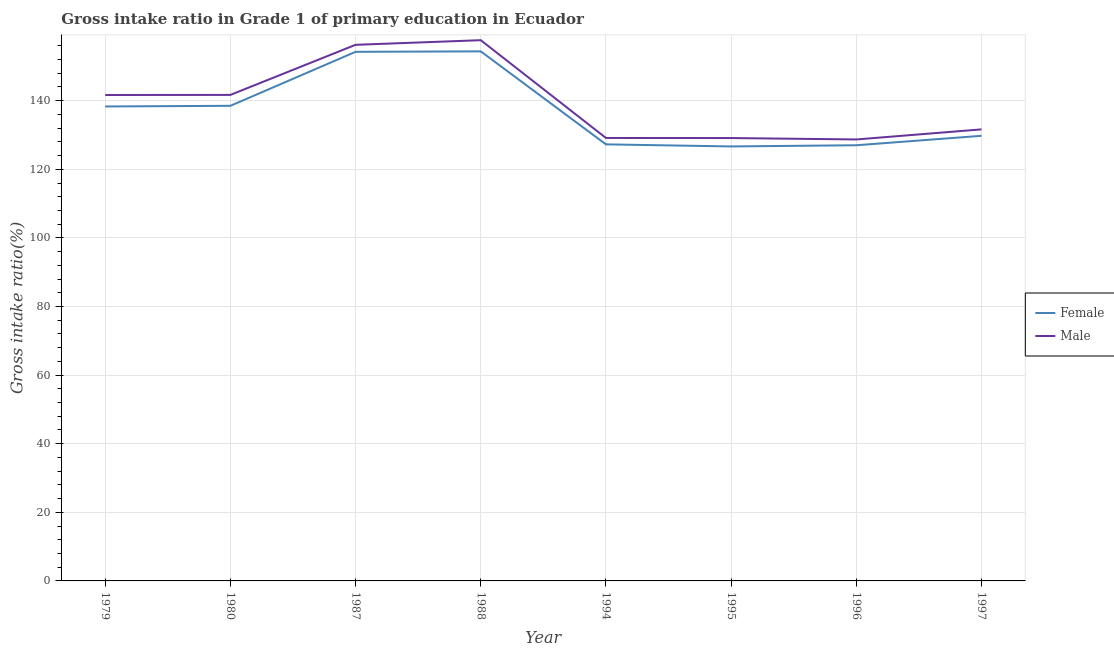Does the line corresponding to gross intake ratio(male) intersect with the line corresponding to gross intake ratio(female)?
Offer a very short reply. No. What is the gross intake ratio(male) in 1979?
Ensure brevity in your answer.  141.65. Across all years, what is the maximum gross intake ratio(female)?
Your answer should be very brief. 154.38. Across all years, what is the minimum gross intake ratio(female)?
Make the answer very short. 126.66. In which year was the gross intake ratio(male) maximum?
Your response must be concise. 1988. In which year was the gross intake ratio(female) minimum?
Your answer should be very brief. 1995. What is the total gross intake ratio(male) in the graph?
Provide a succinct answer. 1115.82. What is the difference between the gross intake ratio(female) in 1987 and that in 1988?
Provide a short and direct response. -0.13. What is the difference between the gross intake ratio(female) in 1979 and the gross intake ratio(male) in 1997?
Provide a succinct answer. 6.68. What is the average gross intake ratio(female) per year?
Provide a succinct answer. 137.02. In the year 1988, what is the difference between the gross intake ratio(female) and gross intake ratio(male)?
Keep it short and to the point. -3.26. In how many years, is the gross intake ratio(female) greater than 44 %?
Offer a terse response. 8. What is the ratio of the gross intake ratio(female) in 1979 to that in 1994?
Your answer should be compact. 1.09. What is the difference between the highest and the second highest gross intake ratio(male)?
Provide a short and direct response. 1.35. What is the difference between the highest and the lowest gross intake ratio(male)?
Keep it short and to the point. 28.94. In how many years, is the gross intake ratio(male) greater than the average gross intake ratio(male) taken over all years?
Provide a succinct answer. 4. Is the gross intake ratio(female) strictly greater than the gross intake ratio(male) over the years?
Ensure brevity in your answer.  No. Is the gross intake ratio(male) strictly less than the gross intake ratio(female) over the years?
Ensure brevity in your answer.  No. How many years are there in the graph?
Your answer should be very brief. 8. What is the difference between two consecutive major ticks on the Y-axis?
Provide a short and direct response. 20. Are the values on the major ticks of Y-axis written in scientific E-notation?
Offer a terse response. No. Does the graph contain any zero values?
Your response must be concise. No. How many legend labels are there?
Make the answer very short. 2. What is the title of the graph?
Provide a short and direct response. Gross intake ratio in Grade 1 of primary education in Ecuador. Does "Services" appear as one of the legend labels in the graph?
Make the answer very short. No. What is the label or title of the Y-axis?
Offer a terse response. Gross intake ratio(%). What is the Gross intake ratio(%) of Female in 1979?
Keep it short and to the point. 138.31. What is the Gross intake ratio(%) of Male in 1979?
Ensure brevity in your answer.  141.65. What is the Gross intake ratio(%) in Female in 1980?
Make the answer very short. 138.5. What is the Gross intake ratio(%) of Male in 1980?
Your response must be concise. 141.68. What is the Gross intake ratio(%) in Female in 1987?
Your answer should be very brief. 154.24. What is the Gross intake ratio(%) of Male in 1987?
Your response must be concise. 156.29. What is the Gross intake ratio(%) in Female in 1988?
Offer a very short reply. 154.38. What is the Gross intake ratio(%) of Male in 1988?
Offer a terse response. 157.63. What is the Gross intake ratio(%) of Female in 1994?
Your answer should be very brief. 127.26. What is the Gross intake ratio(%) in Male in 1994?
Offer a very short reply. 129.13. What is the Gross intake ratio(%) in Female in 1995?
Your response must be concise. 126.66. What is the Gross intake ratio(%) of Male in 1995?
Ensure brevity in your answer.  129.11. What is the Gross intake ratio(%) of Female in 1996?
Offer a very short reply. 127.01. What is the Gross intake ratio(%) of Male in 1996?
Your response must be concise. 128.69. What is the Gross intake ratio(%) of Female in 1997?
Offer a very short reply. 129.76. What is the Gross intake ratio(%) of Male in 1997?
Give a very brief answer. 131.63. Across all years, what is the maximum Gross intake ratio(%) of Female?
Your answer should be very brief. 154.38. Across all years, what is the maximum Gross intake ratio(%) in Male?
Your response must be concise. 157.63. Across all years, what is the minimum Gross intake ratio(%) of Female?
Ensure brevity in your answer.  126.66. Across all years, what is the minimum Gross intake ratio(%) of Male?
Give a very brief answer. 128.69. What is the total Gross intake ratio(%) of Female in the graph?
Offer a very short reply. 1096.13. What is the total Gross intake ratio(%) in Male in the graph?
Give a very brief answer. 1115.82. What is the difference between the Gross intake ratio(%) of Female in 1979 and that in 1980?
Your response must be concise. -0.19. What is the difference between the Gross intake ratio(%) in Male in 1979 and that in 1980?
Give a very brief answer. -0.03. What is the difference between the Gross intake ratio(%) of Female in 1979 and that in 1987?
Keep it short and to the point. -15.93. What is the difference between the Gross intake ratio(%) of Male in 1979 and that in 1987?
Offer a very short reply. -14.63. What is the difference between the Gross intake ratio(%) of Female in 1979 and that in 1988?
Keep it short and to the point. -16.06. What is the difference between the Gross intake ratio(%) of Male in 1979 and that in 1988?
Make the answer very short. -15.98. What is the difference between the Gross intake ratio(%) of Female in 1979 and that in 1994?
Offer a very short reply. 11.05. What is the difference between the Gross intake ratio(%) in Male in 1979 and that in 1994?
Your answer should be very brief. 12.52. What is the difference between the Gross intake ratio(%) in Female in 1979 and that in 1995?
Offer a terse response. 11.65. What is the difference between the Gross intake ratio(%) of Male in 1979 and that in 1995?
Your answer should be compact. 12.55. What is the difference between the Gross intake ratio(%) of Female in 1979 and that in 1996?
Provide a short and direct response. 11.31. What is the difference between the Gross intake ratio(%) in Male in 1979 and that in 1996?
Offer a terse response. 12.96. What is the difference between the Gross intake ratio(%) of Female in 1979 and that in 1997?
Ensure brevity in your answer.  8.55. What is the difference between the Gross intake ratio(%) in Male in 1979 and that in 1997?
Offer a very short reply. 10.02. What is the difference between the Gross intake ratio(%) in Female in 1980 and that in 1987?
Your response must be concise. -15.74. What is the difference between the Gross intake ratio(%) of Male in 1980 and that in 1987?
Give a very brief answer. -14.6. What is the difference between the Gross intake ratio(%) in Female in 1980 and that in 1988?
Ensure brevity in your answer.  -15.87. What is the difference between the Gross intake ratio(%) of Male in 1980 and that in 1988?
Offer a terse response. -15.95. What is the difference between the Gross intake ratio(%) in Female in 1980 and that in 1994?
Provide a short and direct response. 11.24. What is the difference between the Gross intake ratio(%) of Male in 1980 and that in 1994?
Your response must be concise. 12.55. What is the difference between the Gross intake ratio(%) of Female in 1980 and that in 1995?
Your answer should be very brief. 11.84. What is the difference between the Gross intake ratio(%) of Male in 1980 and that in 1995?
Your answer should be very brief. 12.58. What is the difference between the Gross intake ratio(%) in Female in 1980 and that in 1996?
Your answer should be very brief. 11.5. What is the difference between the Gross intake ratio(%) of Male in 1980 and that in 1996?
Offer a terse response. 12.99. What is the difference between the Gross intake ratio(%) in Female in 1980 and that in 1997?
Make the answer very short. 8.74. What is the difference between the Gross intake ratio(%) of Male in 1980 and that in 1997?
Offer a terse response. 10.05. What is the difference between the Gross intake ratio(%) in Female in 1987 and that in 1988?
Your answer should be very brief. -0.13. What is the difference between the Gross intake ratio(%) in Male in 1987 and that in 1988?
Make the answer very short. -1.35. What is the difference between the Gross intake ratio(%) of Female in 1987 and that in 1994?
Your response must be concise. 26.98. What is the difference between the Gross intake ratio(%) in Male in 1987 and that in 1994?
Keep it short and to the point. 27.16. What is the difference between the Gross intake ratio(%) in Female in 1987 and that in 1995?
Give a very brief answer. 27.58. What is the difference between the Gross intake ratio(%) in Male in 1987 and that in 1995?
Offer a terse response. 27.18. What is the difference between the Gross intake ratio(%) of Female in 1987 and that in 1996?
Offer a very short reply. 27.24. What is the difference between the Gross intake ratio(%) of Male in 1987 and that in 1996?
Ensure brevity in your answer.  27.59. What is the difference between the Gross intake ratio(%) of Female in 1987 and that in 1997?
Offer a terse response. 24.48. What is the difference between the Gross intake ratio(%) in Male in 1987 and that in 1997?
Provide a succinct answer. 24.65. What is the difference between the Gross intake ratio(%) of Female in 1988 and that in 1994?
Your answer should be compact. 27.11. What is the difference between the Gross intake ratio(%) of Male in 1988 and that in 1994?
Provide a succinct answer. 28.5. What is the difference between the Gross intake ratio(%) of Female in 1988 and that in 1995?
Your answer should be very brief. 27.72. What is the difference between the Gross intake ratio(%) of Male in 1988 and that in 1995?
Your answer should be very brief. 28.53. What is the difference between the Gross intake ratio(%) of Female in 1988 and that in 1996?
Offer a terse response. 27.37. What is the difference between the Gross intake ratio(%) of Male in 1988 and that in 1996?
Your answer should be compact. 28.94. What is the difference between the Gross intake ratio(%) of Female in 1988 and that in 1997?
Keep it short and to the point. 24.62. What is the difference between the Gross intake ratio(%) of Male in 1988 and that in 1997?
Make the answer very short. 26. What is the difference between the Gross intake ratio(%) of Female in 1994 and that in 1995?
Your answer should be very brief. 0.6. What is the difference between the Gross intake ratio(%) of Male in 1994 and that in 1995?
Your answer should be very brief. 0.02. What is the difference between the Gross intake ratio(%) of Female in 1994 and that in 1996?
Give a very brief answer. 0.26. What is the difference between the Gross intake ratio(%) in Male in 1994 and that in 1996?
Your answer should be very brief. 0.44. What is the difference between the Gross intake ratio(%) of Female in 1994 and that in 1997?
Ensure brevity in your answer.  -2.49. What is the difference between the Gross intake ratio(%) in Male in 1994 and that in 1997?
Give a very brief answer. -2.51. What is the difference between the Gross intake ratio(%) in Female in 1995 and that in 1996?
Offer a very short reply. -0.35. What is the difference between the Gross intake ratio(%) of Male in 1995 and that in 1996?
Keep it short and to the point. 0.41. What is the difference between the Gross intake ratio(%) in Female in 1995 and that in 1997?
Keep it short and to the point. -3.1. What is the difference between the Gross intake ratio(%) in Male in 1995 and that in 1997?
Offer a very short reply. -2.53. What is the difference between the Gross intake ratio(%) of Female in 1996 and that in 1997?
Offer a terse response. -2.75. What is the difference between the Gross intake ratio(%) of Male in 1996 and that in 1997?
Your response must be concise. -2.94. What is the difference between the Gross intake ratio(%) of Female in 1979 and the Gross intake ratio(%) of Male in 1980?
Your answer should be compact. -3.37. What is the difference between the Gross intake ratio(%) in Female in 1979 and the Gross intake ratio(%) in Male in 1987?
Ensure brevity in your answer.  -17.97. What is the difference between the Gross intake ratio(%) in Female in 1979 and the Gross intake ratio(%) in Male in 1988?
Your answer should be compact. -19.32. What is the difference between the Gross intake ratio(%) in Female in 1979 and the Gross intake ratio(%) in Male in 1994?
Provide a short and direct response. 9.18. What is the difference between the Gross intake ratio(%) in Female in 1979 and the Gross intake ratio(%) in Male in 1995?
Provide a succinct answer. 9.2. What is the difference between the Gross intake ratio(%) in Female in 1979 and the Gross intake ratio(%) in Male in 1996?
Give a very brief answer. 9.62. What is the difference between the Gross intake ratio(%) in Female in 1979 and the Gross intake ratio(%) in Male in 1997?
Provide a succinct answer. 6.68. What is the difference between the Gross intake ratio(%) in Female in 1980 and the Gross intake ratio(%) in Male in 1987?
Make the answer very short. -17.78. What is the difference between the Gross intake ratio(%) in Female in 1980 and the Gross intake ratio(%) in Male in 1988?
Ensure brevity in your answer.  -19.13. What is the difference between the Gross intake ratio(%) in Female in 1980 and the Gross intake ratio(%) in Male in 1994?
Provide a succinct answer. 9.38. What is the difference between the Gross intake ratio(%) in Female in 1980 and the Gross intake ratio(%) in Male in 1995?
Your answer should be very brief. 9.4. What is the difference between the Gross intake ratio(%) in Female in 1980 and the Gross intake ratio(%) in Male in 1996?
Ensure brevity in your answer.  9.81. What is the difference between the Gross intake ratio(%) in Female in 1980 and the Gross intake ratio(%) in Male in 1997?
Your answer should be compact. 6.87. What is the difference between the Gross intake ratio(%) in Female in 1987 and the Gross intake ratio(%) in Male in 1988?
Provide a short and direct response. -3.39. What is the difference between the Gross intake ratio(%) in Female in 1987 and the Gross intake ratio(%) in Male in 1994?
Give a very brief answer. 25.11. What is the difference between the Gross intake ratio(%) in Female in 1987 and the Gross intake ratio(%) in Male in 1995?
Keep it short and to the point. 25.14. What is the difference between the Gross intake ratio(%) of Female in 1987 and the Gross intake ratio(%) of Male in 1996?
Ensure brevity in your answer.  25.55. What is the difference between the Gross intake ratio(%) of Female in 1987 and the Gross intake ratio(%) of Male in 1997?
Ensure brevity in your answer.  22.61. What is the difference between the Gross intake ratio(%) in Female in 1988 and the Gross intake ratio(%) in Male in 1994?
Make the answer very short. 25.25. What is the difference between the Gross intake ratio(%) in Female in 1988 and the Gross intake ratio(%) in Male in 1995?
Your answer should be very brief. 25.27. What is the difference between the Gross intake ratio(%) in Female in 1988 and the Gross intake ratio(%) in Male in 1996?
Make the answer very short. 25.68. What is the difference between the Gross intake ratio(%) of Female in 1988 and the Gross intake ratio(%) of Male in 1997?
Your answer should be compact. 22.74. What is the difference between the Gross intake ratio(%) in Female in 1994 and the Gross intake ratio(%) in Male in 1995?
Offer a very short reply. -1.84. What is the difference between the Gross intake ratio(%) in Female in 1994 and the Gross intake ratio(%) in Male in 1996?
Your answer should be compact. -1.43. What is the difference between the Gross intake ratio(%) in Female in 1994 and the Gross intake ratio(%) in Male in 1997?
Ensure brevity in your answer.  -4.37. What is the difference between the Gross intake ratio(%) in Female in 1995 and the Gross intake ratio(%) in Male in 1996?
Ensure brevity in your answer.  -2.03. What is the difference between the Gross intake ratio(%) in Female in 1995 and the Gross intake ratio(%) in Male in 1997?
Your response must be concise. -4.97. What is the difference between the Gross intake ratio(%) of Female in 1996 and the Gross intake ratio(%) of Male in 1997?
Give a very brief answer. -4.63. What is the average Gross intake ratio(%) in Female per year?
Provide a short and direct response. 137.02. What is the average Gross intake ratio(%) of Male per year?
Offer a very short reply. 139.48. In the year 1979, what is the difference between the Gross intake ratio(%) of Female and Gross intake ratio(%) of Male?
Provide a short and direct response. -3.34. In the year 1980, what is the difference between the Gross intake ratio(%) in Female and Gross intake ratio(%) in Male?
Offer a terse response. -3.18. In the year 1987, what is the difference between the Gross intake ratio(%) of Female and Gross intake ratio(%) of Male?
Provide a short and direct response. -2.04. In the year 1988, what is the difference between the Gross intake ratio(%) in Female and Gross intake ratio(%) in Male?
Give a very brief answer. -3.26. In the year 1994, what is the difference between the Gross intake ratio(%) of Female and Gross intake ratio(%) of Male?
Ensure brevity in your answer.  -1.86. In the year 1995, what is the difference between the Gross intake ratio(%) in Female and Gross intake ratio(%) in Male?
Keep it short and to the point. -2.45. In the year 1996, what is the difference between the Gross intake ratio(%) of Female and Gross intake ratio(%) of Male?
Offer a very short reply. -1.69. In the year 1997, what is the difference between the Gross intake ratio(%) of Female and Gross intake ratio(%) of Male?
Provide a short and direct response. -1.88. What is the ratio of the Gross intake ratio(%) of Female in 1979 to that in 1987?
Give a very brief answer. 0.9. What is the ratio of the Gross intake ratio(%) of Male in 1979 to that in 1987?
Your answer should be compact. 0.91. What is the ratio of the Gross intake ratio(%) of Female in 1979 to that in 1988?
Provide a short and direct response. 0.9. What is the ratio of the Gross intake ratio(%) in Male in 1979 to that in 1988?
Provide a succinct answer. 0.9. What is the ratio of the Gross intake ratio(%) in Female in 1979 to that in 1994?
Your response must be concise. 1.09. What is the ratio of the Gross intake ratio(%) in Male in 1979 to that in 1994?
Keep it short and to the point. 1.1. What is the ratio of the Gross intake ratio(%) in Female in 1979 to that in 1995?
Keep it short and to the point. 1.09. What is the ratio of the Gross intake ratio(%) of Male in 1979 to that in 1995?
Your answer should be compact. 1.1. What is the ratio of the Gross intake ratio(%) of Female in 1979 to that in 1996?
Your answer should be very brief. 1.09. What is the ratio of the Gross intake ratio(%) in Male in 1979 to that in 1996?
Offer a terse response. 1.1. What is the ratio of the Gross intake ratio(%) in Female in 1979 to that in 1997?
Your answer should be compact. 1.07. What is the ratio of the Gross intake ratio(%) in Male in 1979 to that in 1997?
Ensure brevity in your answer.  1.08. What is the ratio of the Gross intake ratio(%) of Female in 1980 to that in 1987?
Give a very brief answer. 0.9. What is the ratio of the Gross intake ratio(%) in Male in 1980 to that in 1987?
Your response must be concise. 0.91. What is the ratio of the Gross intake ratio(%) in Female in 1980 to that in 1988?
Offer a very short reply. 0.9. What is the ratio of the Gross intake ratio(%) of Male in 1980 to that in 1988?
Keep it short and to the point. 0.9. What is the ratio of the Gross intake ratio(%) of Female in 1980 to that in 1994?
Your answer should be compact. 1.09. What is the ratio of the Gross intake ratio(%) in Male in 1980 to that in 1994?
Your answer should be compact. 1.1. What is the ratio of the Gross intake ratio(%) in Female in 1980 to that in 1995?
Provide a succinct answer. 1.09. What is the ratio of the Gross intake ratio(%) of Male in 1980 to that in 1995?
Your response must be concise. 1.1. What is the ratio of the Gross intake ratio(%) of Female in 1980 to that in 1996?
Ensure brevity in your answer.  1.09. What is the ratio of the Gross intake ratio(%) of Male in 1980 to that in 1996?
Your response must be concise. 1.1. What is the ratio of the Gross intake ratio(%) of Female in 1980 to that in 1997?
Provide a succinct answer. 1.07. What is the ratio of the Gross intake ratio(%) in Male in 1980 to that in 1997?
Make the answer very short. 1.08. What is the ratio of the Gross intake ratio(%) of Female in 1987 to that in 1988?
Your answer should be very brief. 1. What is the ratio of the Gross intake ratio(%) in Female in 1987 to that in 1994?
Ensure brevity in your answer.  1.21. What is the ratio of the Gross intake ratio(%) of Male in 1987 to that in 1994?
Provide a short and direct response. 1.21. What is the ratio of the Gross intake ratio(%) in Female in 1987 to that in 1995?
Offer a very short reply. 1.22. What is the ratio of the Gross intake ratio(%) of Male in 1987 to that in 1995?
Keep it short and to the point. 1.21. What is the ratio of the Gross intake ratio(%) of Female in 1987 to that in 1996?
Your answer should be compact. 1.21. What is the ratio of the Gross intake ratio(%) in Male in 1987 to that in 1996?
Your answer should be very brief. 1.21. What is the ratio of the Gross intake ratio(%) in Female in 1987 to that in 1997?
Keep it short and to the point. 1.19. What is the ratio of the Gross intake ratio(%) in Male in 1987 to that in 1997?
Provide a short and direct response. 1.19. What is the ratio of the Gross intake ratio(%) in Female in 1988 to that in 1994?
Make the answer very short. 1.21. What is the ratio of the Gross intake ratio(%) in Male in 1988 to that in 1994?
Your answer should be very brief. 1.22. What is the ratio of the Gross intake ratio(%) in Female in 1988 to that in 1995?
Give a very brief answer. 1.22. What is the ratio of the Gross intake ratio(%) of Male in 1988 to that in 1995?
Make the answer very short. 1.22. What is the ratio of the Gross intake ratio(%) in Female in 1988 to that in 1996?
Give a very brief answer. 1.22. What is the ratio of the Gross intake ratio(%) of Male in 1988 to that in 1996?
Offer a very short reply. 1.22. What is the ratio of the Gross intake ratio(%) in Female in 1988 to that in 1997?
Your response must be concise. 1.19. What is the ratio of the Gross intake ratio(%) of Male in 1988 to that in 1997?
Offer a terse response. 1.2. What is the ratio of the Gross intake ratio(%) of Male in 1994 to that in 1995?
Offer a very short reply. 1. What is the ratio of the Gross intake ratio(%) of Female in 1994 to that in 1996?
Your answer should be very brief. 1. What is the ratio of the Gross intake ratio(%) in Female in 1994 to that in 1997?
Give a very brief answer. 0.98. What is the ratio of the Gross intake ratio(%) in Female in 1995 to that in 1997?
Give a very brief answer. 0.98. What is the ratio of the Gross intake ratio(%) in Male in 1995 to that in 1997?
Your answer should be compact. 0.98. What is the ratio of the Gross intake ratio(%) of Female in 1996 to that in 1997?
Offer a terse response. 0.98. What is the ratio of the Gross intake ratio(%) of Male in 1996 to that in 1997?
Your answer should be very brief. 0.98. What is the difference between the highest and the second highest Gross intake ratio(%) in Female?
Make the answer very short. 0.13. What is the difference between the highest and the second highest Gross intake ratio(%) in Male?
Offer a very short reply. 1.35. What is the difference between the highest and the lowest Gross intake ratio(%) of Female?
Make the answer very short. 27.72. What is the difference between the highest and the lowest Gross intake ratio(%) of Male?
Offer a terse response. 28.94. 